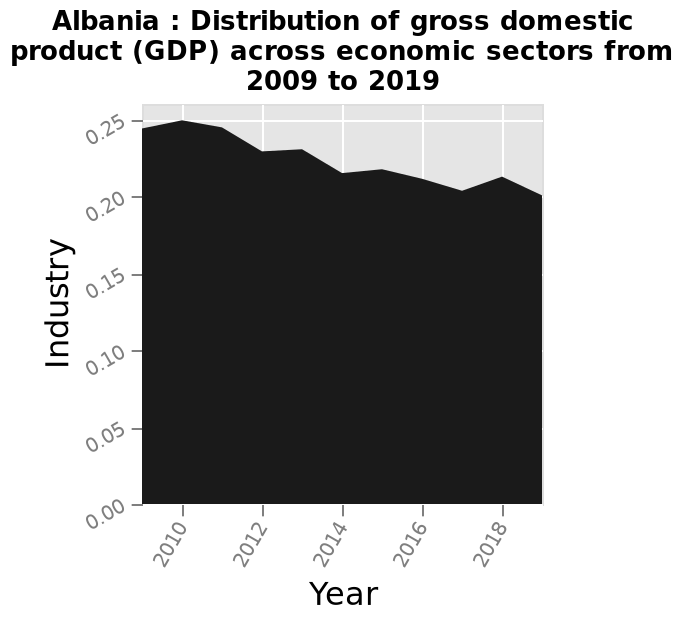<image>
What is the general trend in GDP between 2009 to 2019?  The general trend is for a reduction of GDP between 2009 to 2019. What is the name of the area plot?  The name of the area plot is "Albania: Distribution of gross domestic product (GDP) across economic sectors from 2009 to 2019." 